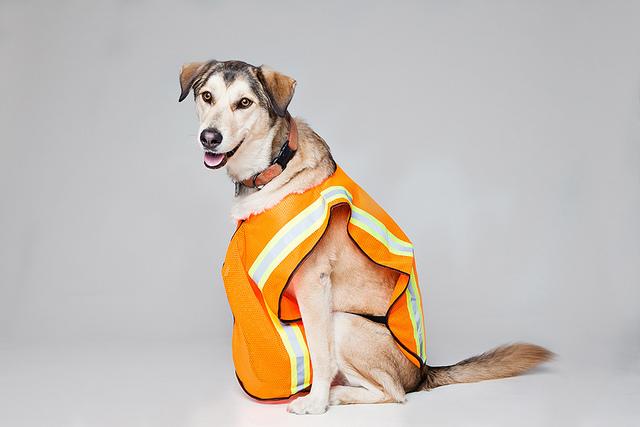What is the dog wearing?
Concise answer only. Safety vest. What breed of dog is this?
Quick response, please. German shepherd. Is the dog laying down?
Quick response, please. No. How many animals are in the image?
Answer briefly. 1. Is this picture staged or candid?
Write a very short answer. Staged. What kind of dog is this?
Answer briefly. No idea. What Kind of dog is this?
Answer briefly. Lab. 